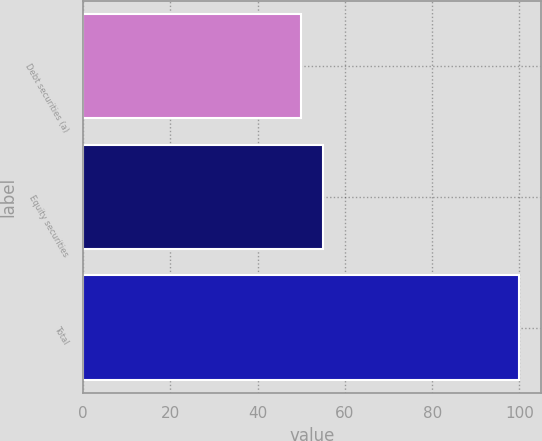Convert chart to OTSL. <chart><loc_0><loc_0><loc_500><loc_500><bar_chart><fcel>Debt securities (a)<fcel>Equity securities<fcel>Total<nl><fcel>50<fcel>55<fcel>100<nl></chart> 